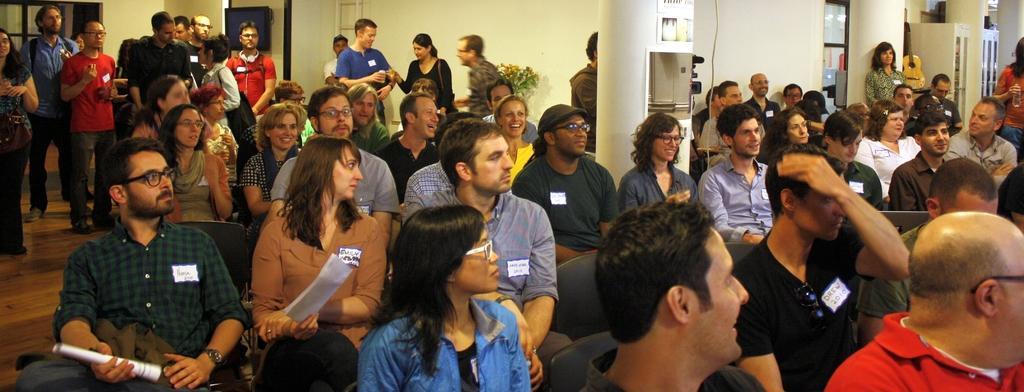Can you describe this image briefly? In this image people are sitting on chairs. Background there is a guitar, cupboards, door, pillars and television. Posters are on the pillar. Far there is a plant. These people are holding papers. 